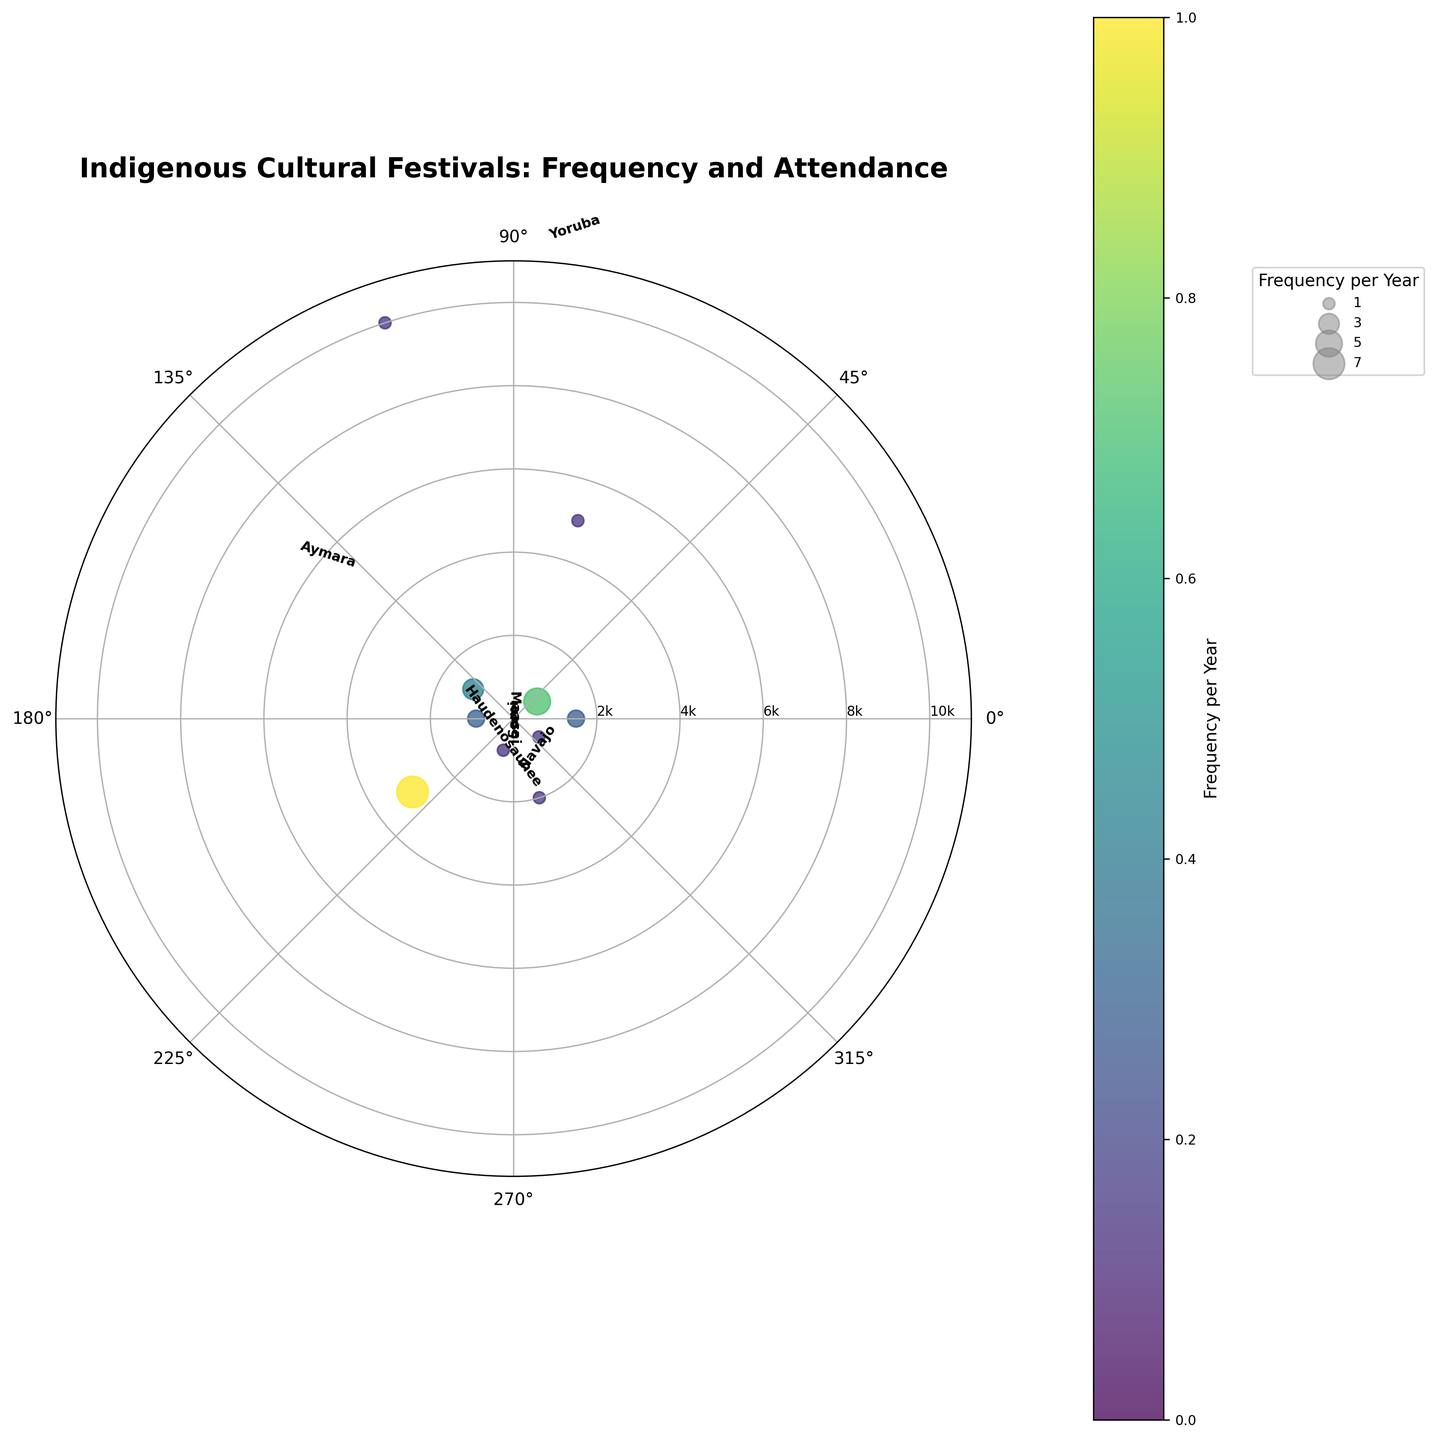What is the title of the figure? The title of the figure is usually placed at the top and is clearly labeled in bold, providing a quick overview of what the plot represents.
Answer: Indigenous Cultural Festivals: Frequency and Attendance How many festivals are plotted in the figure? Count the number of distinct data points or labels around the polar plot.
Answer: 10 Which community has the highest average attendance? Locate the point on the plot which has the highest radial distance from the center, as average attendance is represented by the radius.
Answer: Yoruba Which community’s festival occurs most frequently? Identify the community with the largest marker size and its color, as the frequency is coded by the size and color.
Answer: Maori Are there any communities with the same event frequency? Check if any data points have the same color and are of the same or similar sizes.
Answer: Yes What is the total average attendance for all festivals combined? Sum up the radial distances (average attendances) of all points on the plot. Average Attendance: 1500 + 700 + 5000 + 10000 + 1200 + 900 + 3000 + 800 + 2000 + 750 = 24850
Answer: 24850 Compare the average attendances of the Maasai and Navajo festivals. Which is greater? Look at the radial distances for Maasai and Navajo and compare them. Maasai: 1500, Navajo: 1200.
Answer: Maasai Which festival has the lowest average attendance? Identify the community with the smallest radial distance from the center, as the lowest average attendance is represented by the smallest radius.
Answer: Aboriginal Which community has a festival in both the USA and Canada? Look for the community labels and locate those that cover both locations; further control can be based on coordinates and labels on the circumference.
Answer: Haudenosaunee 